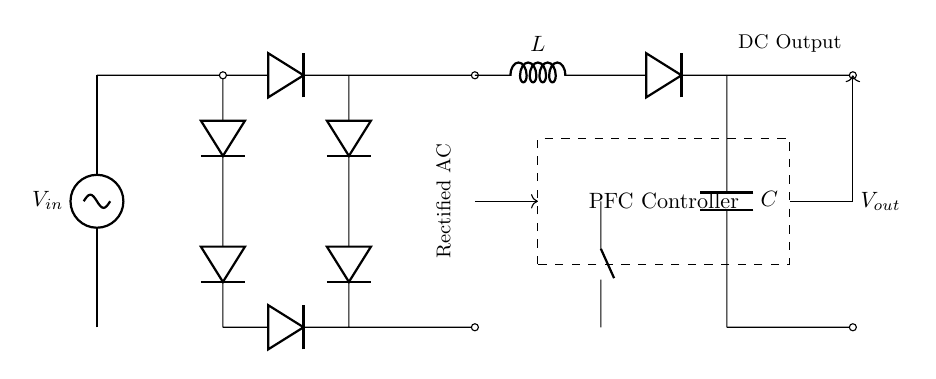What is the input voltage in the circuit? The input voltage is represented by the symbol V sub in, which denotes the source voltage connected at the top of the circuit diagram.
Answer: V in What type of rectifier is used in this circuit? The circuit utilizes a bridge rectifier, identifiable through the arrangement of four diodes forming a bridge configuration that converts AC to DC.
Answer: Bridge rectifier What is the role of the PFC controller? The PFC controller is designated to manage the power factor correction, indicating its function to control and minimize the phase difference between voltage and current to enhance efficiency.
Answer: Power factor correction What component is used for energy storage in this circuit? The component used for energy storage is identified as capacitor C, which links the output to store electric charge for stable voltage output.
Answer: Capacitor How does the boost converter affect output voltage? The boost converter, consisting of an inductor and a diode connected to a capacitor, increases the output voltage relative to the input voltage by storing energy in the inductor and then releasing it.
Answer: Increases output voltage Which component is responsible for filtering in the circuit? The capacitor C is responsible for filtering, as it smoothens the DC output by reducing voltage ripple after rectification and conversion processes.
Answer: Capacitor What does the arrow signify in the feedback section? The arrow in the feedback section indicates the direction of control signals sent from the PFC controller back to the circuit elements, essential for maintaining the desired operational parameters.
Answer: Control signal 